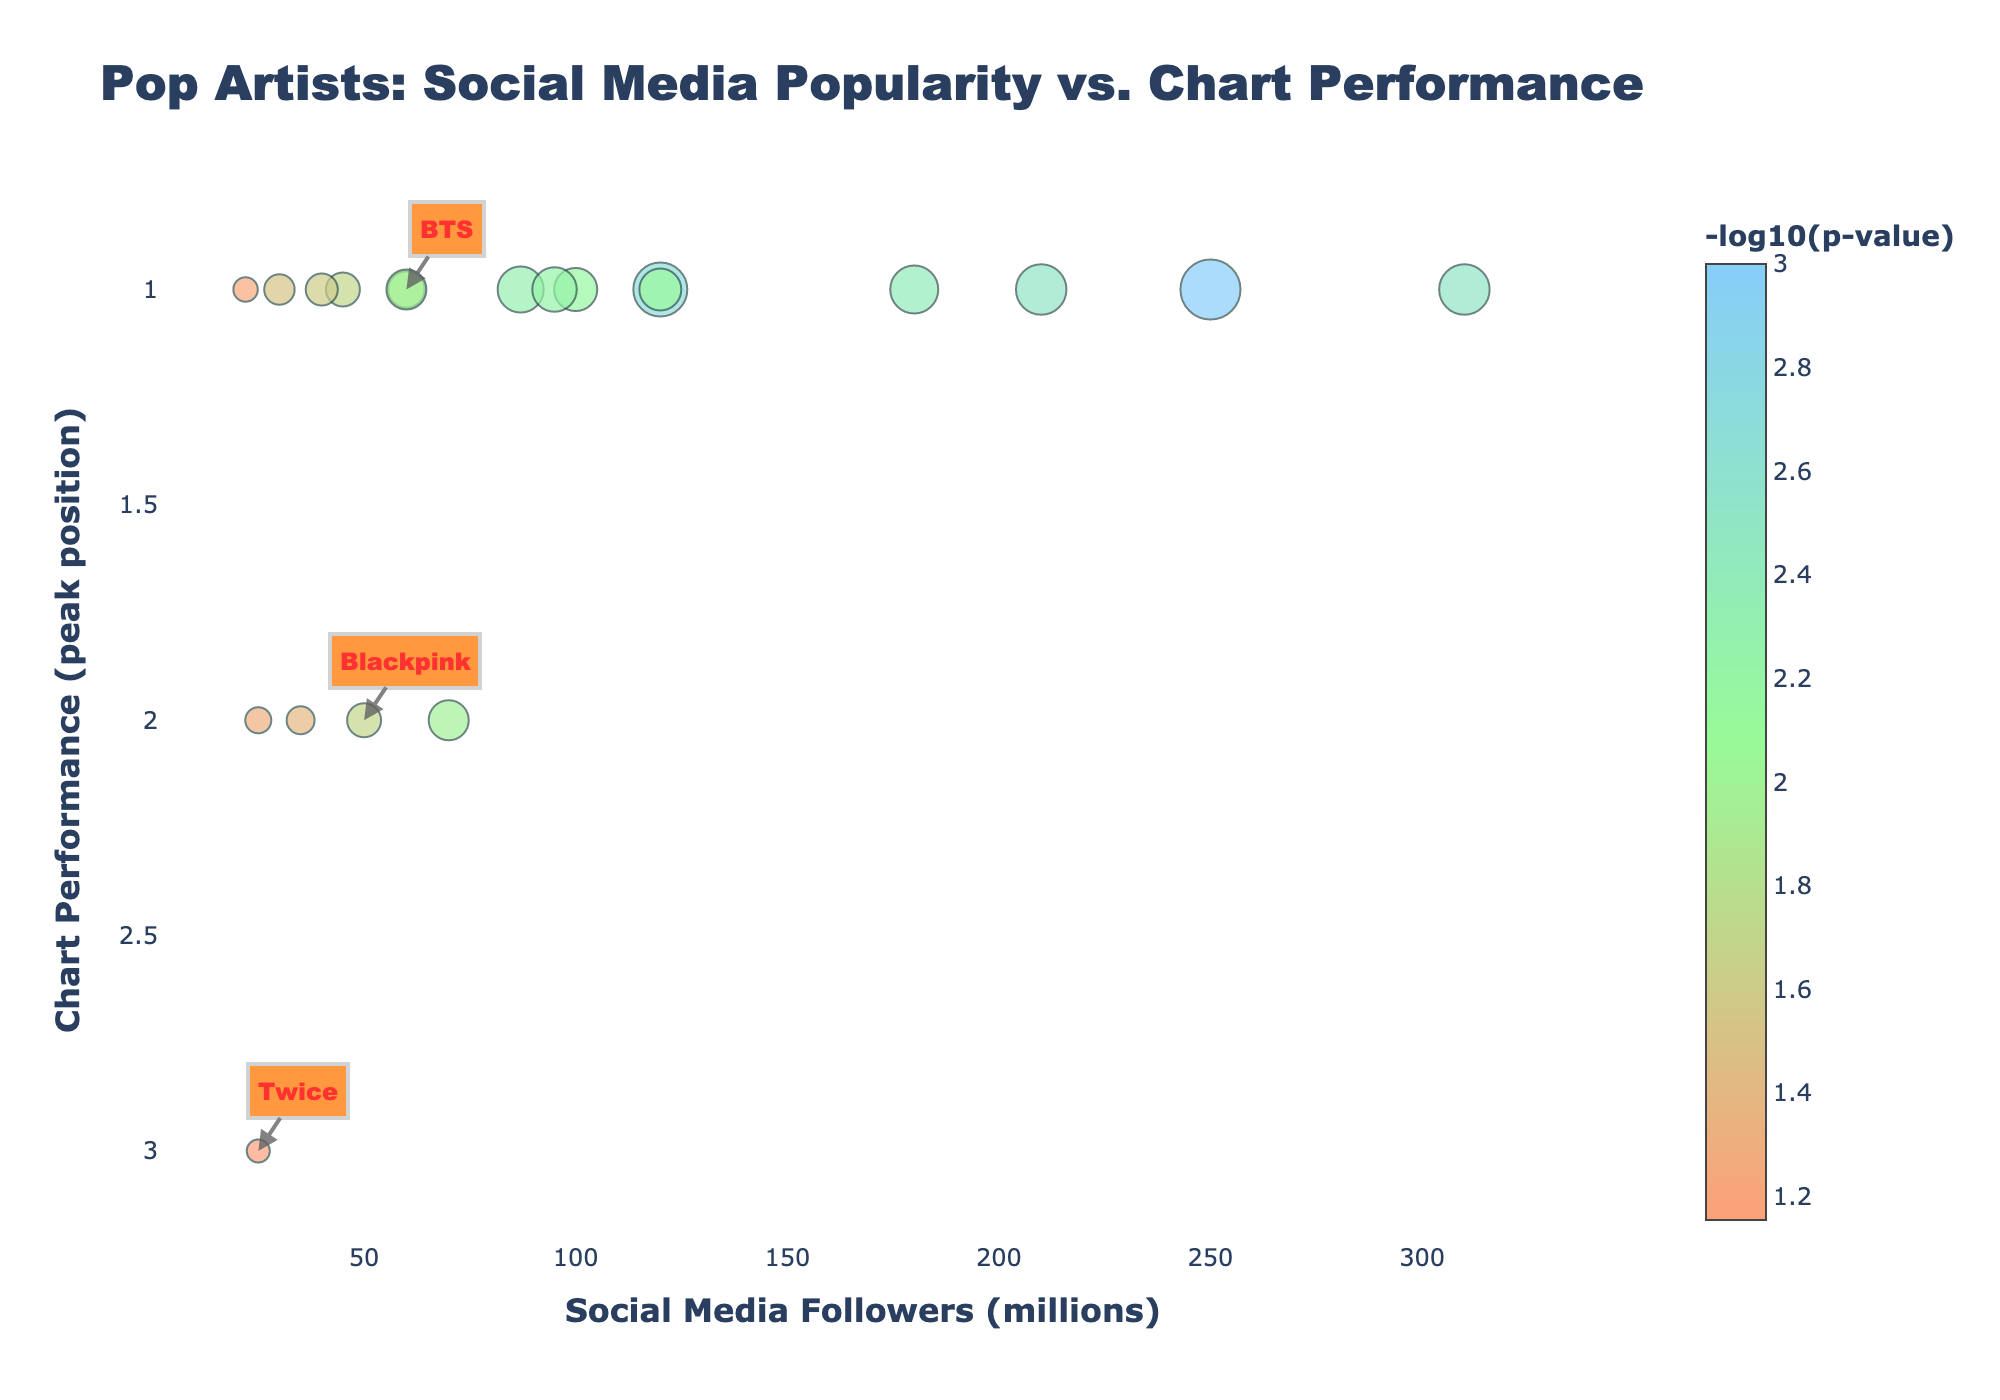What's the title of the plot? The title is usually found at the top of the plot, often in a larger and bold font for better visibility. In this case, the title is "<b>Pop Artists: Social Media Popularity vs. Chart Performance</b>".
Answer: Pop Artists: Social Media Popularity vs. Chart Performance How does the color scale represent -log10(p-value) on the plot? The color scale, shown as a gradient color bar next to the plot, indicates different values of -log10(p-value). In this plot, it ranges from one color to another (e.g., from light pink to blue), showing the variations in -log10(p-value) for different artists.
Answer: It uses a gradient color bar Which artist has the highest social media followers in the plot? By examining the x-axis, which represents social media followers in millions, and locating the rightmost point, we identify the artist. Selena Gomez, with 310 million followers, is the rightmost point.
Answer: Selena Gomez What's the average chart performance position of artists with more than 200 million followers? First, identify artists with followers more than 200 million: Taylor Swift, Ariana Grande, and Selena Gomez. Then, average their chart performance positions (all of which are 1).
Answer: 1 Who are the Asian artists annotated on the plot? The plot annotations highlight Asian artists, marked with arrows and text. These artists are BTS, Blackpink, and Twice.
Answer: BTS, Blackpink, Twice Which artist among the annotated Asian artists has the highest chart performance? By examining the chart performance of the annotated Asian artists, noting that a lower number represents better performance, BTS and Blackpink both have a peak position of 1.
Answer: BTS and Blackpink Which artist has the smallest p-value? Using the color and size of the points related to -log10(p-value), the smallest p-value corresponds to the largest -log10(p-value). The largest point, located by checking each annotation, shows Taylor Swift with the smallest p-value of 0.001.
Answer: Taylor Swift How many artists have peak chart performance at position 1? Count the points that align with a chart performance position of 1 on the y-axis. There are 14 points in this category.
Answer: 14 Compare the social media followers of Charlie Puth and Twice. Who has more? Locate Charlie Puth and Twice points on the x-axis (social media followers). Charlie Puth has 25 million, which is the same as Twice's 25 million.
Answer: Equal (both have 25 million) What trend, if any, can be observed between social media followers and chart performance? Analyze whether higher social media followers correspond with better (lower) chart performance positions. The plot shows that several top performers, including Taylor Swift and Selena Gomez, have both high social media followers and excellent chart performance, suggesting a positive trend.
Answer: Higher social media followers often coincide with better chart performance 